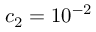Convert formula to latex. <formula><loc_0><loc_0><loc_500><loc_500>c _ { 2 } = 1 0 ^ { - 2 }</formula> 